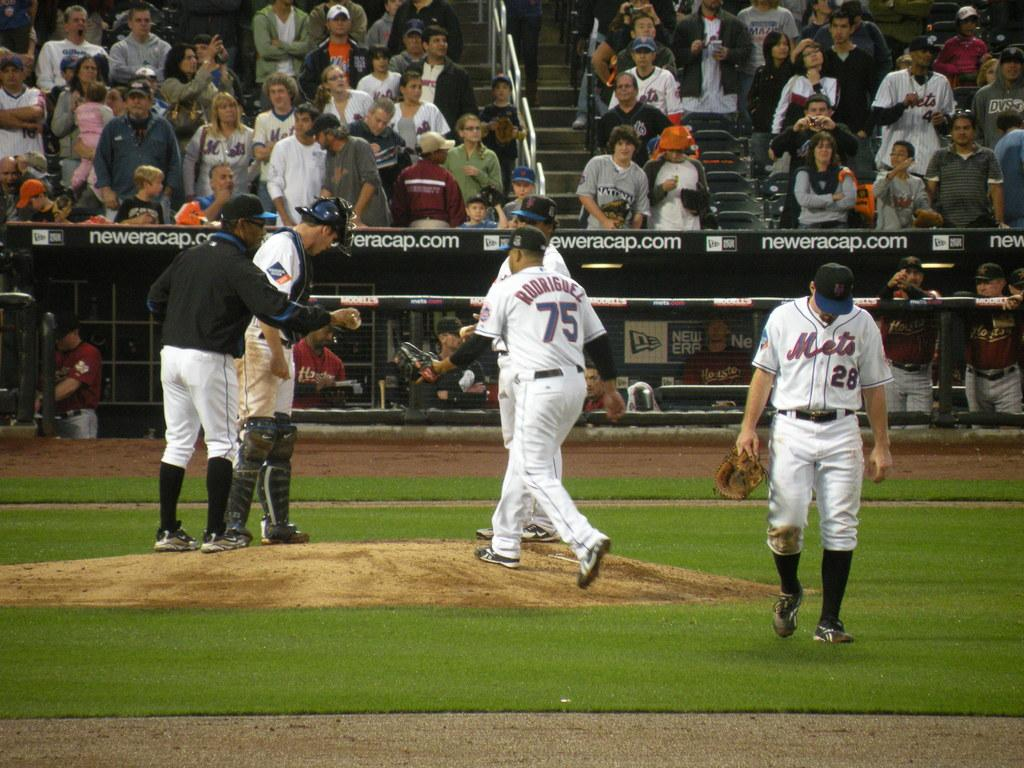<image>
Share a concise interpretation of the image provided. A group of Mets baseball player near the pitchers mound. 